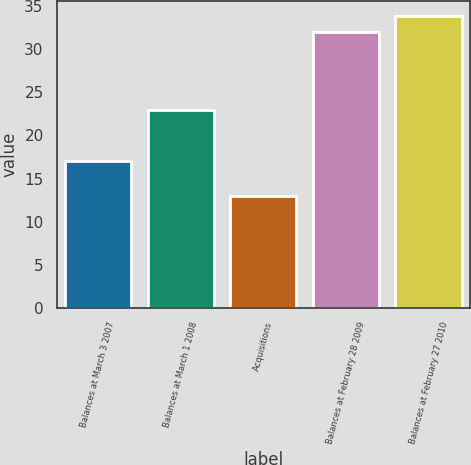Convert chart. <chart><loc_0><loc_0><loc_500><loc_500><bar_chart><fcel>Balances at March 3 2007<fcel>Balances at March 1 2008<fcel>Acquisitions<fcel>Balances at February 28 2009<fcel>Balances at February 27 2010<nl><fcel>17<fcel>23<fcel>13<fcel>32<fcel>33.9<nl></chart> 